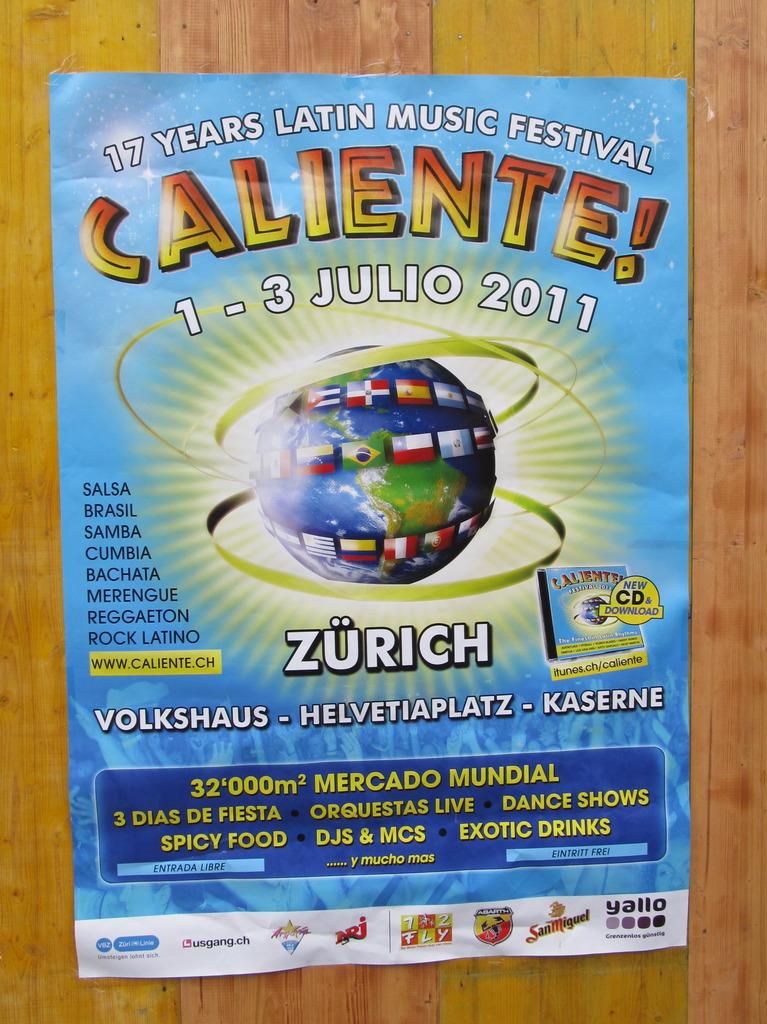What is the name of this music festival?
Offer a very short reply. Caliente. 